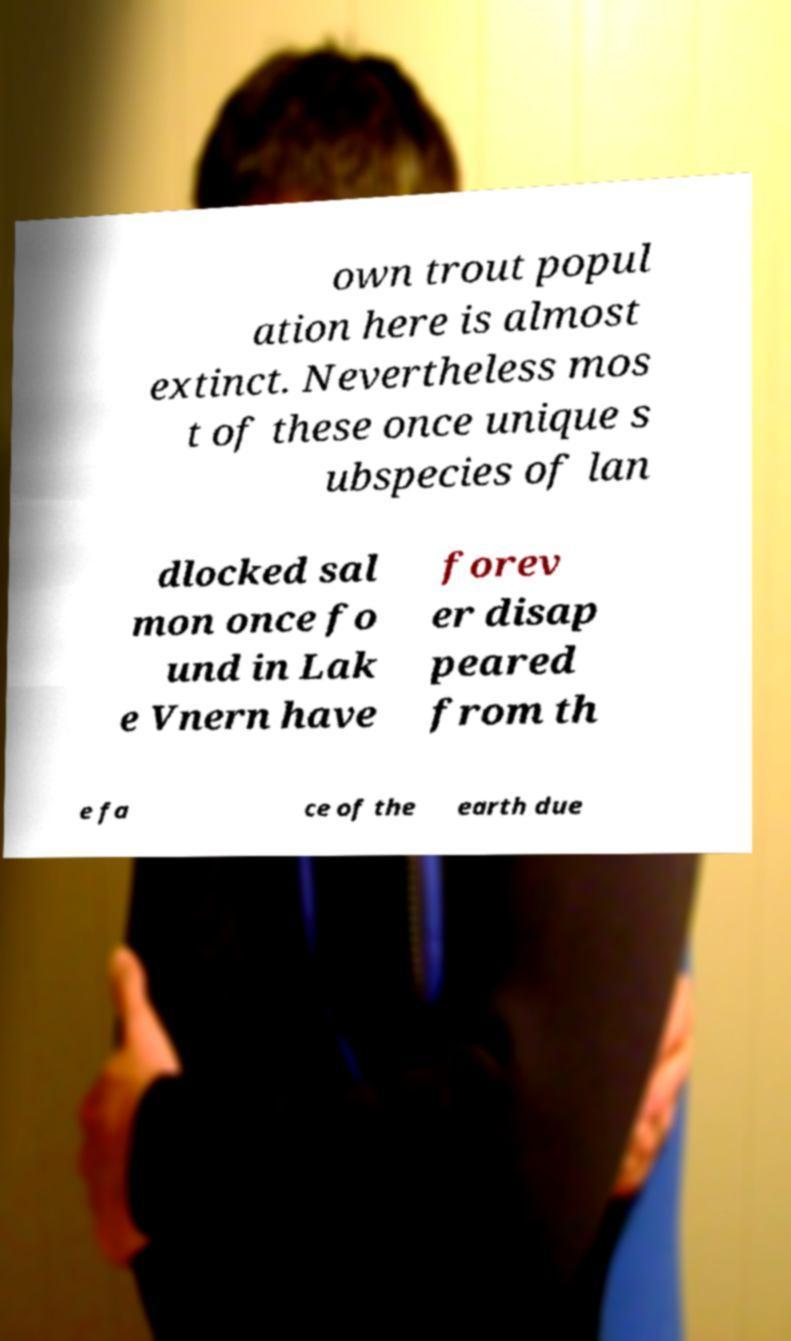Can you accurately transcribe the text from the provided image for me? own trout popul ation here is almost extinct. Nevertheless mos t of these once unique s ubspecies of lan dlocked sal mon once fo und in Lak e Vnern have forev er disap peared from th e fa ce of the earth due 